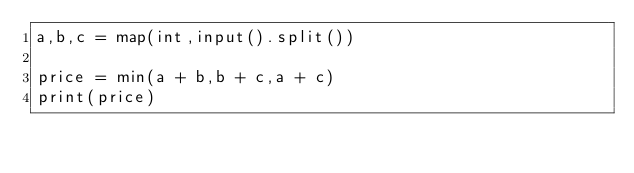<code> <loc_0><loc_0><loc_500><loc_500><_Python_>a,b,c = map(int,input().split())

price = min(a + b,b + c,a + c)
print(price)
</code> 